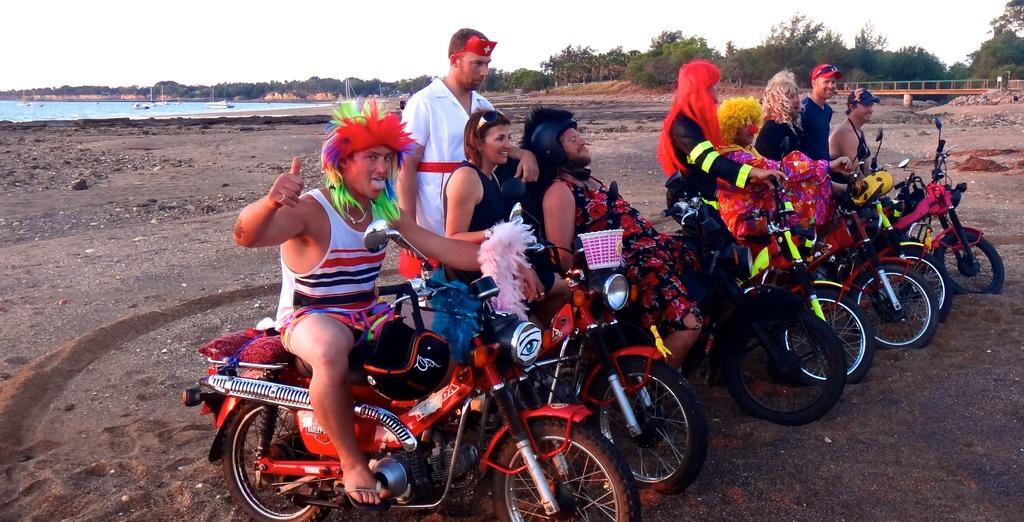Where was the image taken? The image was taken outdoors. What are the people in the image doing? The people are sitting on a motor vehicle. What are the people wearing? The people are wearing fancy dress. What can be seen in the background of the image? There are trees, the sky, and water visible in the background of the image. What type of stocking is being used to hold the sheet in place in the image? There is no stocking or sheet present in the image. How much butter is visible on the motor vehicle in the image? There is no butter visible on the motor vehicle in the image. 